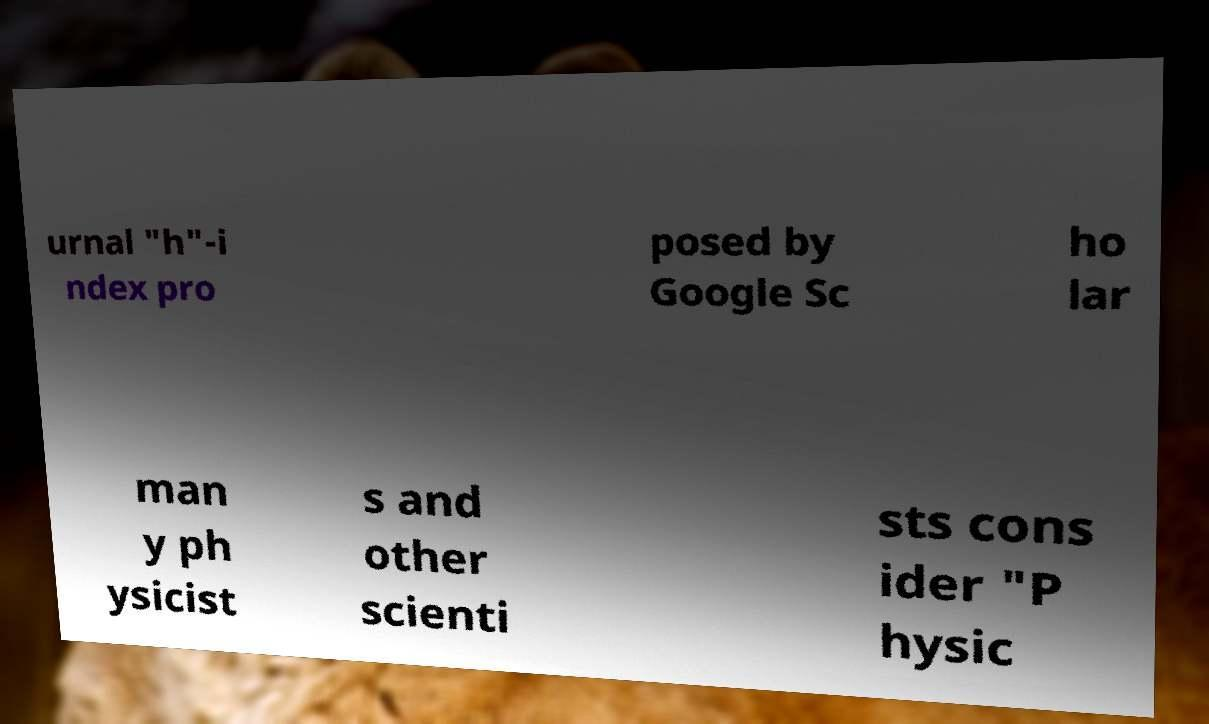What messages or text are displayed in this image? I need them in a readable, typed format. urnal "h"-i ndex pro posed by Google Sc ho lar man y ph ysicist s and other scienti sts cons ider "P hysic 